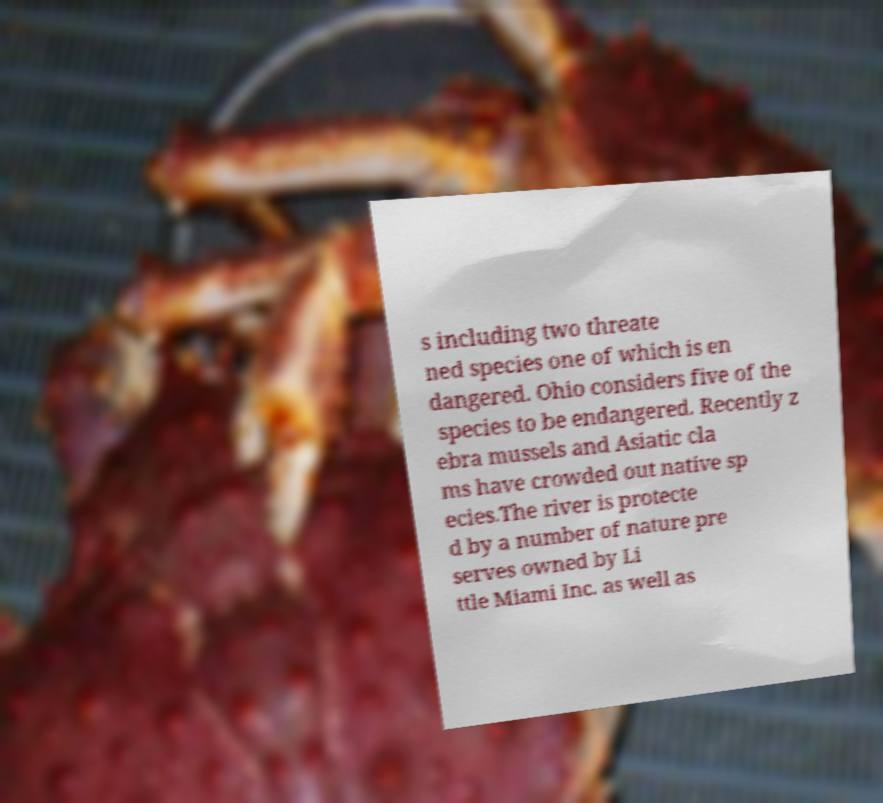There's text embedded in this image that I need extracted. Can you transcribe it verbatim? s including two threate ned species one of which is en dangered. Ohio considers five of the species to be endangered. Recently z ebra mussels and Asiatic cla ms have crowded out native sp ecies.The river is protecte d by a number of nature pre serves owned by Li ttle Miami Inc. as well as 